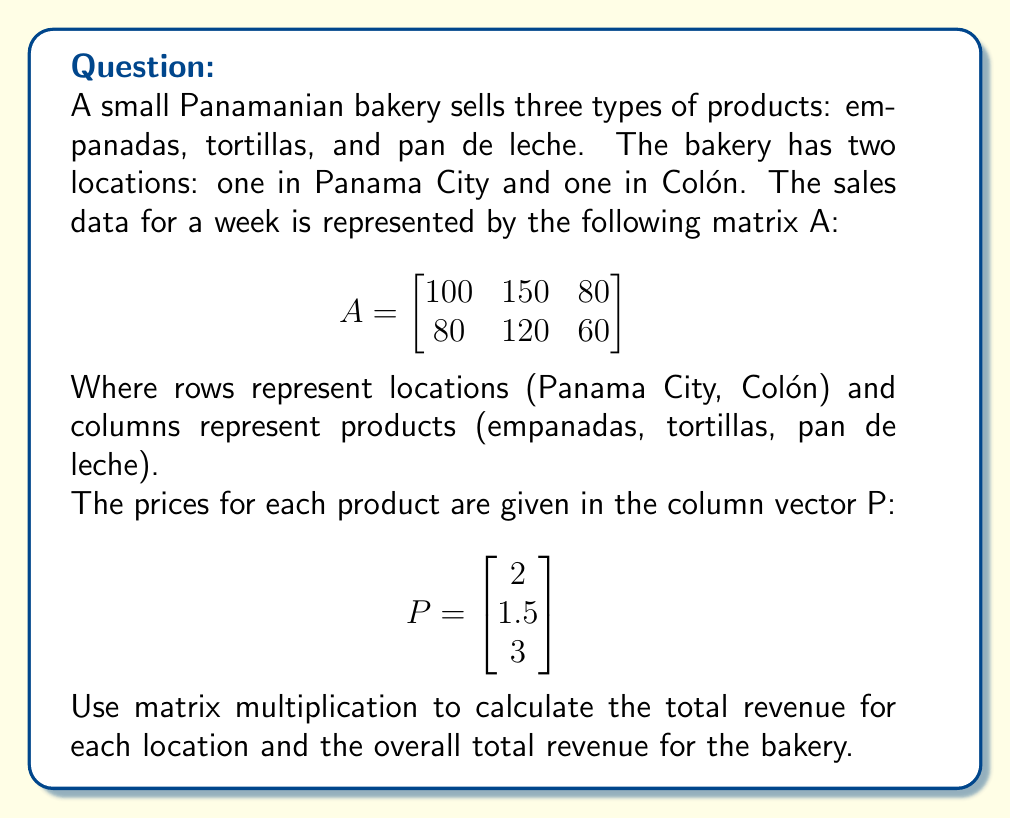Provide a solution to this math problem. To solve this problem, we need to multiply matrix A by vector P. This multiplication will give us a column vector with the total revenue for each location.

Step 1: Set up the matrix multiplication
$$R = A \times P = \begin{bmatrix}
100 & 150 & 80 \\
80 & 120 & 60
\end{bmatrix} \times \begin{bmatrix}
2 \\
1.5 \\
3
\end{bmatrix}$$

Step 2: Perform the multiplication
For Panama City (first row):
$R_1 = (100 \times 2) + (150 \times 1.5) + (80 \times 3) = 200 + 225 + 240 = 665$

For Colón (second row):
$R_2 = (80 \times 2) + (120 \times 1.5) + (60 \times 3) = 160 + 180 + 180 = 520$

Step 3: Write the result as a column vector
$$R = \begin{bmatrix}
665 \\
520
\end{bmatrix}$$

Step 4: Calculate the overall total revenue
Total Revenue = $665 + 520 = 1185$

The result shows that the total revenue for the Panama City location is $665, the total revenue for the Colón location is $520, and the overall total revenue for the bakery is $1185.
Answer: $$R = \begin{bmatrix}
665 \\
520
\end{bmatrix}$$

Total Revenue: $1185 